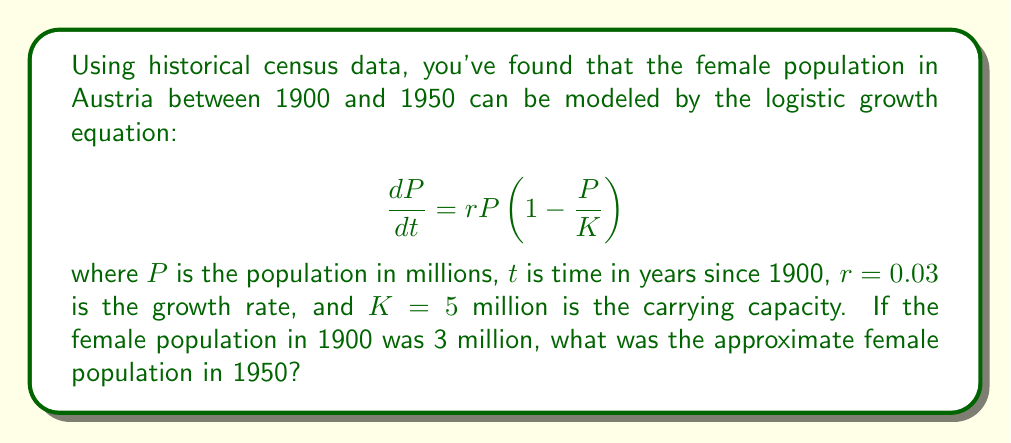Give your solution to this math problem. To solve this problem, we need to use the solution to the logistic growth equation:

$$P(t) = \frac{K}{1 + (\frac{K}{P_0} - 1)e^{-rt}}$$

Where:
- $K = 5$ million (carrying capacity)
- $r = 0.03$ (growth rate)
- $P_0 = 3$ million (initial population in 1900)
- $t = 50$ years (time elapsed from 1900 to 1950)

Let's substitute these values into the equation:

$$P(50) = \frac{5}{1 + (\frac{5}{3} - 1)e^{-0.03 \cdot 50}}$$

Now, let's solve this step-by-step:

1) First, calculate $\frac{K}{P_0} - 1$:
   $\frac{5}{3} - 1 = \frac{2}{3} \approx 0.6667$

2) Calculate $e^{-rt}$:
   $e^{-0.03 \cdot 50} = e^{-1.5} \approx 0.2231$

3) Multiply the results from steps 1 and 2:
   $0.6667 \cdot 0.2231 \approx 0.1487$

4) Add 1 to this result:
   $1 + 0.1487 = 1.1487$

5) Divide $K$ by this result:
   $\frac{5}{1.1487} \approx 4.3528$

Therefore, the female population in Austria in 1950 was approximately 4.35 million.
Answer: 4.35 million 